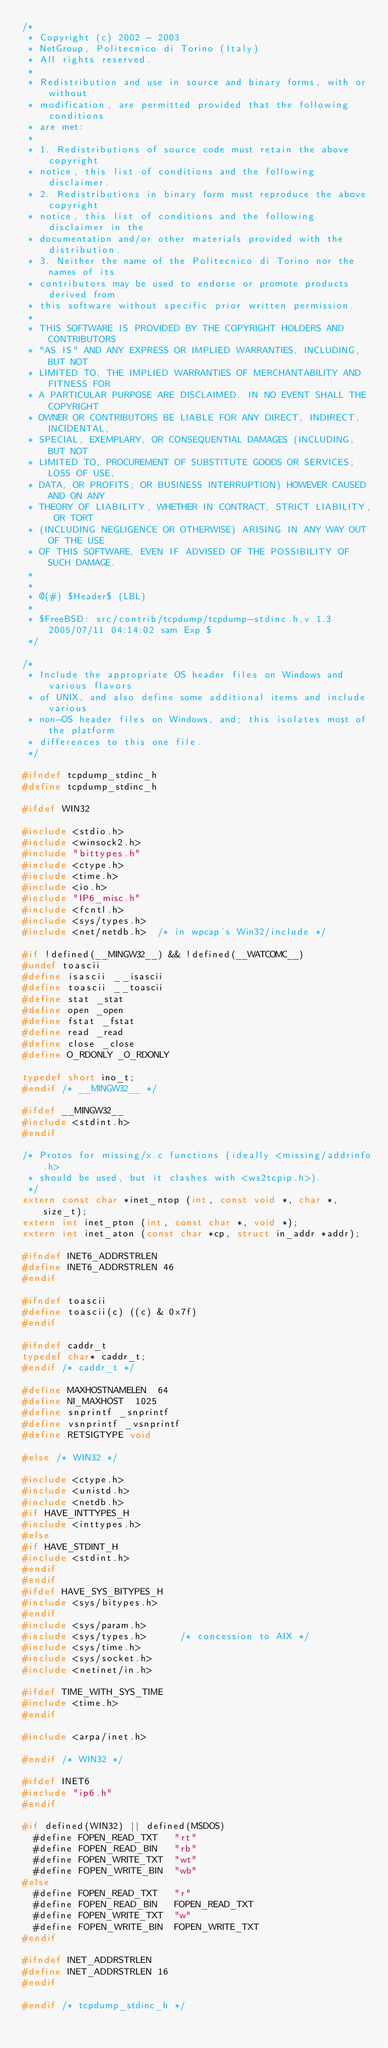Convert code to text. <code><loc_0><loc_0><loc_500><loc_500><_C_>/*
 * Copyright (c) 2002 - 2003
 * NetGroup, Politecnico di Torino (Italy)
 * All rights reserved.
 *
 * Redistribution and use in source and binary forms, with or without
 * modification, are permitted provided that the following conditions
 * are met:
 *
 * 1. Redistributions of source code must retain the above copyright
 * notice, this list of conditions and the following disclaimer.
 * 2. Redistributions in binary form must reproduce the above copyright
 * notice, this list of conditions and the following disclaimer in the
 * documentation and/or other materials provided with the distribution.
 * 3. Neither the name of the Politecnico di Torino nor the names of its
 * contributors may be used to endorse or promote products derived from
 * this software without specific prior written permission.
 *
 * THIS SOFTWARE IS PROVIDED BY THE COPYRIGHT HOLDERS AND CONTRIBUTORS
 * "AS IS" AND ANY EXPRESS OR IMPLIED WARRANTIES, INCLUDING, BUT NOT
 * LIMITED TO, THE IMPLIED WARRANTIES OF MERCHANTABILITY AND FITNESS FOR
 * A PARTICULAR PURPOSE ARE DISCLAIMED. IN NO EVENT SHALL THE COPYRIGHT
 * OWNER OR CONTRIBUTORS BE LIABLE FOR ANY DIRECT, INDIRECT, INCIDENTAL,
 * SPECIAL, EXEMPLARY, OR CONSEQUENTIAL DAMAGES (INCLUDING, BUT NOT
 * LIMITED TO, PROCUREMENT OF SUBSTITUTE GOODS OR SERVICES; LOSS OF USE,
 * DATA, OR PROFITS; OR BUSINESS INTERRUPTION) HOWEVER CAUSED AND ON ANY
 * THEORY OF LIABILITY, WHETHER IN CONTRACT, STRICT LIABILITY, OR TORT
 * (INCLUDING NEGLIGENCE OR OTHERWISE) ARISING IN ANY WAY OUT OF THE USE
 * OF THIS SOFTWARE, EVEN IF ADVISED OF THE POSSIBILITY OF SUCH DAMAGE.
 *
 *
 * @(#) $Header$ (LBL)
 *
 * $FreeBSD: src/contrib/tcpdump/tcpdump-stdinc.h,v 1.3 2005/07/11 04:14:02 sam Exp $
 */

/*
 * Include the appropriate OS header files on Windows and various flavors
 * of UNIX, and also define some additional items and include various
 * non-OS header files on Windows, and; this isolates most of the platform
 * differences to this one file.
 */

#ifndef tcpdump_stdinc_h
#define tcpdump_stdinc_h

#ifdef WIN32

#include <stdio.h>
#include <winsock2.h>
#include "bittypes.h"
#include <ctype.h>
#include <time.h>
#include <io.h>
#include "IP6_misc.h"
#include <fcntl.h>
#include <sys/types.h>
#include <net/netdb.h>  /* in wpcap's Win32/include */

#if !defined(__MINGW32__) && !defined(__WATCOMC__)
#undef toascii
#define isascii __isascii
#define toascii __toascii
#define stat _stat
#define open _open
#define fstat _fstat
#define read _read
#define close _close
#define O_RDONLY _O_RDONLY

typedef short ino_t;
#endif /* __MINGW32__ */

#ifdef __MINGW32__
#include <stdint.h>
#endif

/* Protos for missing/x.c functions (ideally <missing/addrinfo.h>
 * should be used, but it clashes with <ws2tcpip.h>).
 */
extern const char *inet_ntop (int, const void *, char *, size_t);
extern int inet_pton (int, const char *, void *);
extern int inet_aton (const char *cp, struct in_addr *addr);

#ifndef INET6_ADDRSTRLEN
#define INET6_ADDRSTRLEN 46
#endif

#ifndef toascii
#define toascii(c) ((c) & 0x7f)
#endif

#ifndef caddr_t
typedef char* caddr_t;
#endif /* caddr_t */

#define MAXHOSTNAMELEN	64
#define	NI_MAXHOST	1025
#define snprintf _snprintf
#define vsnprintf _vsnprintf
#define RETSIGTYPE void

#else /* WIN32 */

#include <ctype.h>
#include <unistd.h>
#include <netdb.h>
#if HAVE_INTTYPES_H
#include <inttypes.h>
#else
#if HAVE_STDINT_H
#include <stdint.h>
#endif
#endif
#ifdef HAVE_SYS_BITYPES_H
#include <sys/bitypes.h>
#endif
#include <sys/param.h>
#include <sys/types.h>			/* concession to AIX */
#include <sys/time.h>
#include <sys/socket.h>
#include <netinet/in.h>

#ifdef TIME_WITH_SYS_TIME
#include <time.h>
#endif

#include <arpa/inet.h>

#endif /* WIN32 */

#ifdef INET6
#include "ip6.h"
#endif

#if defined(WIN32) || defined(MSDOS)
  #define FOPEN_READ_TXT   "rt"
  #define FOPEN_READ_BIN   "rb"
  #define FOPEN_WRITE_TXT  "wt"
  #define FOPEN_WRITE_BIN  "wb"
#else
  #define FOPEN_READ_TXT   "r"
  #define FOPEN_READ_BIN   FOPEN_READ_TXT
  #define FOPEN_WRITE_TXT  "w"
  #define FOPEN_WRITE_BIN  FOPEN_WRITE_TXT
#endif

#ifndef INET_ADDRSTRLEN
#define INET_ADDRSTRLEN 16
#endif

#endif /* tcpdump_stdinc_h */
</code> 